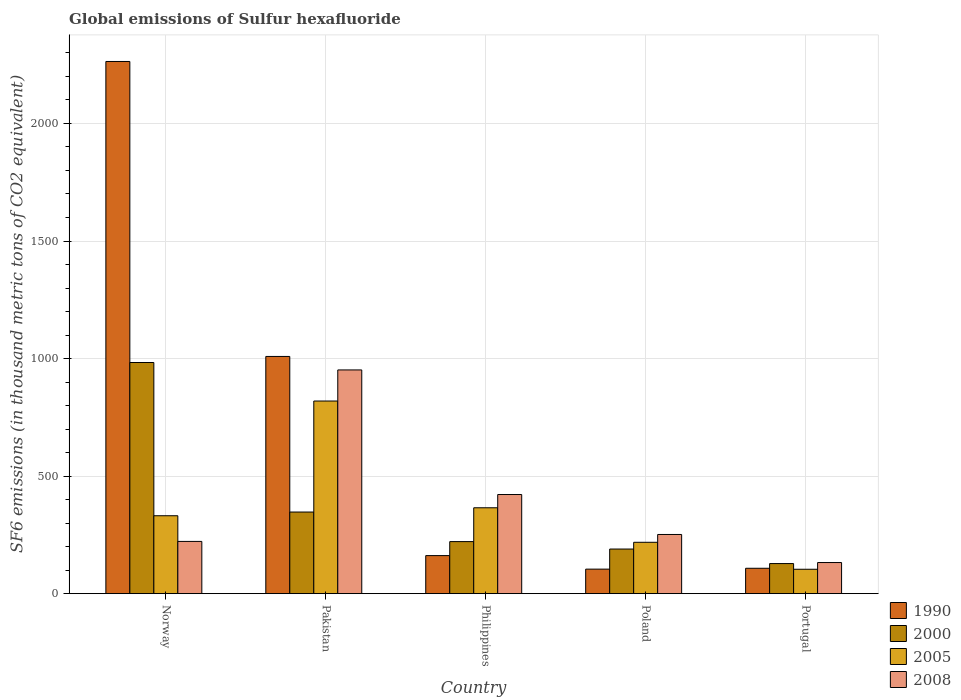How many groups of bars are there?
Ensure brevity in your answer.  5. Are the number of bars per tick equal to the number of legend labels?
Your answer should be compact. Yes. Are the number of bars on each tick of the X-axis equal?
Ensure brevity in your answer.  Yes. How many bars are there on the 1st tick from the left?
Provide a short and direct response. 4. What is the label of the 5th group of bars from the left?
Provide a succinct answer. Portugal. In how many cases, is the number of bars for a given country not equal to the number of legend labels?
Keep it short and to the point. 0. What is the global emissions of Sulfur hexafluoride in 2000 in Portugal?
Offer a very short reply. 128. Across all countries, what is the maximum global emissions of Sulfur hexafluoride in 2005?
Offer a terse response. 819.4. Across all countries, what is the minimum global emissions of Sulfur hexafluoride in 1990?
Your answer should be compact. 104.3. In which country was the global emissions of Sulfur hexafluoride in 1990 maximum?
Make the answer very short. Norway. In which country was the global emissions of Sulfur hexafluoride in 2005 minimum?
Provide a short and direct response. Portugal. What is the total global emissions of Sulfur hexafluoride in 2000 in the graph?
Provide a short and direct response. 1869.6. What is the difference between the global emissions of Sulfur hexafluoride in 2005 in Philippines and that in Portugal?
Keep it short and to the point. 261.5. What is the difference between the global emissions of Sulfur hexafluoride in 2000 in Poland and the global emissions of Sulfur hexafluoride in 2005 in Philippines?
Your response must be concise. -175.5. What is the average global emissions of Sulfur hexafluoride in 2005 per country?
Ensure brevity in your answer.  367.68. What is the difference between the global emissions of Sulfur hexafluoride of/in 2008 and global emissions of Sulfur hexafluoride of/in 2005 in Norway?
Give a very brief answer. -109.2. What is the ratio of the global emissions of Sulfur hexafluoride in 2000 in Norway to that in Philippines?
Offer a very short reply. 4.44. Is the global emissions of Sulfur hexafluoride in 2008 in Norway less than that in Poland?
Give a very brief answer. Yes. Is the difference between the global emissions of Sulfur hexafluoride in 2008 in Pakistan and Portugal greater than the difference between the global emissions of Sulfur hexafluoride in 2005 in Pakistan and Portugal?
Offer a very short reply. Yes. What is the difference between the highest and the second highest global emissions of Sulfur hexafluoride in 2000?
Your answer should be compact. 125.8. What is the difference between the highest and the lowest global emissions of Sulfur hexafluoride in 2000?
Ensure brevity in your answer.  855.2. What does the 4th bar from the left in Philippines represents?
Your answer should be compact. 2008. What does the 3rd bar from the right in Pakistan represents?
Give a very brief answer. 2000. Is it the case that in every country, the sum of the global emissions of Sulfur hexafluoride in 2005 and global emissions of Sulfur hexafluoride in 1990 is greater than the global emissions of Sulfur hexafluoride in 2000?
Your answer should be compact. Yes. Are all the bars in the graph horizontal?
Make the answer very short. No. Are the values on the major ticks of Y-axis written in scientific E-notation?
Keep it short and to the point. No. Does the graph contain any zero values?
Provide a short and direct response. No. Does the graph contain grids?
Offer a terse response. Yes. Where does the legend appear in the graph?
Give a very brief answer. Bottom right. How are the legend labels stacked?
Make the answer very short. Vertical. What is the title of the graph?
Offer a terse response. Global emissions of Sulfur hexafluoride. What is the label or title of the Y-axis?
Provide a short and direct response. SF6 emissions (in thousand metric tons of CO2 equivalent). What is the SF6 emissions (in thousand metric tons of CO2 equivalent) of 1990 in Norway?
Offer a terse response. 2263.6. What is the SF6 emissions (in thousand metric tons of CO2 equivalent) in 2000 in Norway?
Provide a short and direct response. 983.2. What is the SF6 emissions (in thousand metric tons of CO2 equivalent) of 2005 in Norway?
Your answer should be compact. 331.4. What is the SF6 emissions (in thousand metric tons of CO2 equivalent) of 2008 in Norway?
Ensure brevity in your answer.  222.2. What is the SF6 emissions (in thousand metric tons of CO2 equivalent) of 1990 in Pakistan?
Provide a succinct answer. 1009. What is the SF6 emissions (in thousand metric tons of CO2 equivalent) in 2000 in Pakistan?
Keep it short and to the point. 347.2. What is the SF6 emissions (in thousand metric tons of CO2 equivalent) of 2005 in Pakistan?
Make the answer very short. 819.4. What is the SF6 emissions (in thousand metric tons of CO2 equivalent) of 2008 in Pakistan?
Your answer should be compact. 951.6. What is the SF6 emissions (in thousand metric tons of CO2 equivalent) of 1990 in Philippines?
Your response must be concise. 161.9. What is the SF6 emissions (in thousand metric tons of CO2 equivalent) in 2000 in Philippines?
Your answer should be very brief. 221.4. What is the SF6 emissions (in thousand metric tons of CO2 equivalent) in 2005 in Philippines?
Give a very brief answer. 365.3. What is the SF6 emissions (in thousand metric tons of CO2 equivalent) in 2008 in Philippines?
Your response must be concise. 421.7. What is the SF6 emissions (in thousand metric tons of CO2 equivalent) in 1990 in Poland?
Your response must be concise. 104.3. What is the SF6 emissions (in thousand metric tons of CO2 equivalent) of 2000 in Poland?
Your response must be concise. 189.8. What is the SF6 emissions (in thousand metric tons of CO2 equivalent) of 2005 in Poland?
Offer a very short reply. 218.5. What is the SF6 emissions (in thousand metric tons of CO2 equivalent) of 2008 in Poland?
Give a very brief answer. 251.7. What is the SF6 emissions (in thousand metric tons of CO2 equivalent) in 1990 in Portugal?
Provide a succinct answer. 108. What is the SF6 emissions (in thousand metric tons of CO2 equivalent) in 2000 in Portugal?
Offer a very short reply. 128. What is the SF6 emissions (in thousand metric tons of CO2 equivalent) in 2005 in Portugal?
Offer a terse response. 103.8. What is the SF6 emissions (in thousand metric tons of CO2 equivalent) in 2008 in Portugal?
Your answer should be very brief. 132.4. Across all countries, what is the maximum SF6 emissions (in thousand metric tons of CO2 equivalent) in 1990?
Provide a short and direct response. 2263.6. Across all countries, what is the maximum SF6 emissions (in thousand metric tons of CO2 equivalent) in 2000?
Offer a terse response. 983.2. Across all countries, what is the maximum SF6 emissions (in thousand metric tons of CO2 equivalent) of 2005?
Ensure brevity in your answer.  819.4. Across all countries, what is the maximum SF6 emissions (in thousand metric tons of CO2 equivalent) in 2008?
Provide a succinct answer. 951.6. Across all countries, what is the minimum SF6 emissions (in thousand metric tons of CO2 equivalent) of 1990?
Give a very brief answer. 104.3. Across all countries, what is the minimum SF6 emissions (in thousand metric tons of CO2 equivalent) of 2000?
Provide a short and direct response. 128. Across all countries, what is the minimum SF6 emissions (in thousand metric tons of CO2 equivalent) of 2005?
Offer a terse response. 103.8. Across all countries, what is the minimum SF6 emissions (in thousand metric tons of CO2 equivalent) in 2008?
Make the answer very short. 132.4. What is the total SF6 emissions (in thousand metric tons of CO2 equivalent) in 1990 in the graph?
Keep it short and to the point. 3646.8. What is the total SF6 emissions (in thousand metric tons of CO2 equivalent) of 2000 in the graph?
Provide a succinct answer. 1869.6. What is the total SF6 emissions (in thousand metric tons of CO2 equivalent) in 2005 in the graph?
Your answer should be very brief. 1838.4. What is the total SF6 emissions (in thousand metric tons of CO2 equivalent) of 2008 in the graph?
Provide a succinct answer. 1979.6. What is the difference between the SF6 emissions (in thousand metric tons of CO2 equivalent) of 1990 in Norway and that in Pakistan?
Offer a very short reply. 1254.6. What is the difference between the SF6 emissions (in thousand metric tons of CO2 equivalent) in 2000 in Norway and that in Pakistan?
Provide a short and direct response. 636. What is the difference between the SF6 emissions (in thousand metric tons of CO2 equivalent) of 2005 in Norway and that in Pakistan?
Your answer should be compact. -488. What is the difference between the SF6 emissions (in thousand metric tons of CO2 equivalent) of 2008 in Norway and that in Pakistan?
Provide a succinct answer. -729.4. What is the difference between the SF6 emissions (in thousand metric tons of CO2 equivalent) in 1990 in Norway and that in Philippines?
Your answer should be compact. 2101.7. What is the difference between the SF6 emissions (in thousand metric tons of CO2 equivalent) of 2000 in Norway and that in Philippines?
Your answer should be compact. 761.8. What is the difference between the SF6 emissions (in thousand metric tons of CO2 equivalent) of 2005 in Norway and that in Philippines?
Provide a succinct answer. -33.9. What is the difference between the SF6 emissions (in thousand metric tons of CO2 equivalent) of 2008 in Norway and that in Philippines?
Provide a succinct answer. -199.5. What is the difference between the SF6 emissions (in thousand metric tons of CO2 equivalent) in 1990 in Norway and that in Poland?
Offer a very short reply. 2159.3. What is the difference between the SF6 emissions (in thousand metric tons of CO2 equivalent) of 2000 in Norway and that in Poland?
Make the answer very short. 793.4. What is the difference between the SF6 emissions (in thousand metric tons of CO2 equivalent) in 2005 in Norway and that in Poland?
Ensure brevity in your answer.  112.9. What is the difference between the SF6 emissions (in thousand metric tons of CO2 equivalent) of 2008 in Norway and that in Poland?
Offer a terse response. -29.5. What is the difference between the SF6 emissions (in thousand metric tons of CO2 equivalent) in 1990 in Norway and that in Portugal?
Your answer should be very brief. 2155.6. What is the difference between the SF6 emissions (in thousand metric tons of CO2 equivalent) of 2000 in Norway and that in Portugal?
Your answer should be very brief. 855.2. What is the difference between the SF6 emissions (in thousand metric tons of CO2 equivalent) of 2005 in Norway and that in Portugal?
Keep it short and to the point. 227.6. What is the difference between the SF6 emissions (in thousand metric tons of CO2 equivalent) of 2008 in Norway and that in Portugal?
Provide a succinct answer. 89.8. What is the difference between the SF6 emissions (in thousand metric tons of CO2 equivalent) of 1990 in Pakistan and that in Philippines?
Ensure brevity in your answer.  847.1. What is the difference between the SF6 emissions (in thousand metric tons of CO2 equivalent) in 2000 in Pakistan and that in Philippines?
Your answer should be very brief. 125.8. What is the difference between the SF6 emissions (in thousand metric tons of CO2 equivalent) of 2005 in Pakistan and that in Philippines?
Keep it short and to the point. 454.1. What is the difference between the SF6 emissions (in thousand metric tons of CO2 equivalent) of 2008 in Pakistan and that in Philippines?
Your answer should be compact. 529.9. What is the difference between the SF6 emissions (in thousand metric tons of CO2 equivalent) of 1990 in Pakistan and that in Poland?
Provide a short and direct response. 904.7. What is the difference between the SF6 emissions (in thousand metric tons of CO2 equivalent) of 2000 in Pakistan and that in Poland?
Make the answer very short. 157.4. What is the difference between the SF6 emissions (in thousand metric tons of CO2 equivalent) in 2005 in Pakistan and that in Poland?
Offer a very short reply. 600.9. What is the difference between the SF6 emissions (in thousand metric tons of CO2 equivalent) in 2008 in Pakistan and that in Poland?
Offer a very short reply. 699.9. What is the difference between the SF6 emissions (in thousand metric tons of CO2 equivalent) of 1990 in Pakistan and that in Portugal?
Your answer should be very brief. 901. What is the difference between the SF6 emissions (in thousand metric tons of CO2 equivalent) in 2000 in Pakistan and that in Portugal?
Your answer should be very brief. 219.2. What is the difference between the SF6 emissions (in thousand metric tons of CO2 equivalent) of 2005 in Pakistan and that in Portugal?
Offer a very short reply. 715.6. What is the difference between the SF6 emissions (in thousand metric tons of CO2 equivalent) of 2008 in Pakistan and that in Portugal?
Provide a short and direct response. 819.2. What is the difference between the SF6 emissions (in thousand metric tons of CO2 equivalent) in 1990 in Philippines and that in Poland?
Offer a terse response. 57.6. What is the difference between the SF6 emissions (in thousand metric tons of CO2 equivalent) in 2000 in Philippines and that in Poland?
Offer a very short reply. 31.6. What is the difference between the SF6 emissions (in thousand metric tons of CO2 equivalent) of 2005 in Philippines and that in Poland?
Make the answer very short. 146.8. What is the difference between the SF6 emissions (in thousand metric tons of CO2 equivalent) in 2008 in Philippines and that in Poland?
Offer a terse response. 170. What is the difference between the SF6 emissions (in thousand metric tons of CO2 equivalent) in 1990 in Philippines and that in Portugal?
Offer a very short reply. 53.9. What is the difference between the SF6 emissions (in thousand metric tons of CO2 equivalent) of 2000 in Philippines and that in Portugal?
Your answer should be very brief. 93.4. What is the difference between the SF6 emissions (in thousand metric tons of CO2 equivalent) in 2005 in Philippines and that in Portugal?
Offer a very short reply. 261.5. What is the difference between the SF6 emissions (in thousand metric tons of CO2 equivalent) in 2008 in Philippines and that in Portugal?
Offer a very short reply. 289.3. What is the difference between the SF6 emissions (in thousand metric tons of CO2 equivalent) of 1990 in Poland and that in Portugal?
Ensure brevity in your answer.  -3.7. What is the difference between the SF6 emissions (in thousand metric tons of CO2 equivalent) in 2000 in Poland and that in Portugal?
Provide a short and direct response. 61.8. What is the difference between the SF6 emissions (in thousand metric tons of CO2 equivalent) of 2005 in Poland and that in Portugal?
Offer a terse response. 114.7. What is the difference between the SF6 emissions (in thousand metric tons of CO2 equivalent) of 2008 in Poland and that in Portugal?
Provide a succinct answer. 119.3. What is the difference between the SF6 emissions (in thousand metric tons of CO2 equivalent) of 1990 in Norway and the SF6 emissions (in thousand metric tons of CO2 equivalent) of 2000 in Pakistan?
Offer a terse response. 1916.4. What is the difference between the SF6 emissions (in thousand metric tons of CO2 equivalent) of 1990 in Norway and the SF6 emissions (in thousand metric tons of CO2 equivalent) of 2005 in Pakistan?
Provide a succinct answer. 1444.2. What is the difference between the SF6 emissions (in thousand metric tons of CO2 equivalent) of 1990 in Norway and the SF6 emissions (in thousand metric tons of CO2 equivalent) of 2008 in Pakistan?
Your answer should be compact. 1312. What is the difference between the SF6 emissions (in thousand metric tons of CO2 equivalent) in 2000 in Norway and the SF6 emissions (in thousand metric tons of CO2 equivalent) in 2005 in Pakistan?
Keep it short and to the point. 163.8. What is the difference between the SF6 emissions (in thousand metric tons of CO2 equivalent) of 2000 in Norway and the SF6 emissions (in thousand metric tons of CO2 equivalent) of 2008 in Pakistan?
Your answer should be very brief. 31.6. What is the difference between the SF6 emissions (in thousand metric tons of CO2 equivalent) of 2005 in Norway and the SF6 emissions (in thousand metric tons of CO2 equivalent) of 2008 in Pakistan?
Give a very brief answer. -620.2. What is the difference between the SF6 emissions (in thousand metric tons of CO2 equivalent) of 1990 in Norway and the SF6 emissions (in thousand metric tons of CO2 equivalent) of 2000 in Philippines?
Your answer should be very brief. 2042.2. What is the difference between the SF6 emissions (in thousand metric tons of CO2 equivalent) in 1990 in Norway and the SF6 emissions (in thousand metric tons of CO2 equivalent) in 2005 in Philippines?
Your answer should be compact. 1898.3. What is the difference between the SF6 emissions (in thousand metric tons of CO2 equivalent) in 1990 in Norway and the SF6 emissions (in thousand metric tons of CO2 equivalent) in 2008 in Philippines?
Your answer should be very brief. 1841.9. What is the difference between the SF6 emissions (in thousand metric tons of CO2 equivalent) of 2000 in Norway and the SF6 emissions (in thousand metric tons of CO2 equivalent) of 2005 in Philippines?
Ensure brevity in your answer.  617.9. What is the difference between the SF6 emissions (in thousand metric tons of CO2 equivalent) in 2000 in Norway and the SF6 emissions (in thousand metric tons of CO2 equivalent) in 2008 in Philippines?
Keep it short and to the point. 561.5. What is the difference between the SF6 emissions (in thousand metric tons of CO2 equivalent) of 2005 in Norway and the SF6 emissions (in thousand metric tons of CO2 equivalent) of 2008 in Philippines?
Your answer should be compact. -90.3. What is the difference between the SF6 emissions (in thousand metric tons of CO2 equivalent) in 1990 in Norway and the SF6 emissions (in thousand metric tons of CO2 equivalent) in 2000 in Poland?
Keep it short and to the point. 2073.8. What is the difference between the SF6 emissions (in thousand metric tons of CO2 equivalent) of 1990 in Norway and the SF6 emissions (in thousand metric tons of CO2 equivalent) of 2005 in Poland?
Offer a very short reply. 2045.1. What is the difference between the SF6 emissions (in thousand metric tons of CO2 equivalent) of 1990 in Norway and the SF6 emissions (in thousand metric tons of CO2 equivalent) of 2008 in Poland?
Your answer should be very brief. 2011.9. What is the difference between the SF6 emissions (in thousand metric tons of CO2 equivalent) of 2000 in Norway and the SF6 emissions (in thousand metric tons of CO2 equivalent) of 2005 in Poland?
Your answer should be very brief. 764.7. What is the difference between the SF6 emissions (in thousand metric tons of CO2 equivalent) in 2000 in Norway and the SF6 emissions (in thousand metric tons of CO2 equivalent) in 2008 in Poland?
Offer a very short reply. 731.5. What is the difference between the SF6 emissions (in thousand metric tons of CO2 equivalent) in 2005 in Norway and the SF6 emissions (in thousand metric tons of CO2 equivalent) in 2008 in Poland?
Provide a succinct answer. 79.7. What is the difference between the SF6 emissions (in thousand metric tons of CO2 equivalent) of 1990 in Norway and the SF6 emissions (in thousand metric tons of CO2 equivalent) of 2000 in Portugal?
Your answer should be very brief. 2135.6. What is the difference between the SF6 emissions (in thousand metric tons of CO2 equivalent) in 1990 in Norway and the SF6 emissions (in thousand metric tons of CO2 equivalent) in 2005 in Portugal?
Offer a very short reply. 2159.8. What is the difference between the SF6 emissions (in thousand metric tons of CO2 equivalent) of 1990 in Norway and the SF6 emissions (in thousand metric tons of CO2 equivalent) of 2008 in Portugal?
Your answer should be compact. 2131.2. What is the difference between the SF6 emissions (in thousand metric tons of CO2 equivalent) of 2000 in Norway and the SF6 emissions (in thousand metric tons of CO2 equivalent) of 2005 in Portugal?
Your answer should be compact. 879.4. What is the difference between the SF6 emissions (in thousand metric tons of CO2 equivalent) in 2000 in Norway and the SF6 emissions (in thousand metric tons of CO2 equivalent) in 2008 in Portugal?
Keep it short and to the point. 850.8. What is the difference between the SF6 emissions (in thousand metric tons of CO2 equivalent) in 2005 in Norway and the SF6 emissions (in thousand metric tons of CO2 equivalent) in 2008 in Portugal?
Offer a terse response. 199. What is the difference between the SF6 emissions (in thousand metric tons of CO2 equivalent) in 1990 in Pakistan and the SF6 emissions (in thousand metric tons of CO2 equivalent) in 2000 in Philippines?
Keep it short and to the point. 787.6. What is the difference between the SF6 emissions (in thousand metric tons of CO2 equivalent) in 1990 in Pakistan and the SF6 emissions (in thousand metric tons of CO2 equivalent) in 2005 in Philippines?
Ensure brevity in your answer.  643.7. What is the difference between the SF6 emissions (in thousand metric tons of CO2 equivalent) of 1990 in Pakistan and the SF6 emissions (in thousand metric tons of CO2 equivalent) of 2008 in Philippines?
Ensure brevity in your answer.  587.3. What is the difference between the SF6 emissions (in thousand metric tons of CO2 equivalent) in 2000 in Pakistan and the SF6 emissions (in thousand metric tons of CO2 equivalent) in 2005 in Philippines?
Offer a very short reply. -18.1. What is the difference between the SF6 emissions (in thousand metric tons of CO2 equivalent) of 2000 in Pakistan and the SF6 emissions (in thousand metric tons of CO2 equivalent) of 2008 in Philippines?
Keep it short and to the point. -74.5. What is the difference between the SF6 emissions (in thousand metric tons of CO2 equivalent) of 2005 in Pakistan and the SF6 emissions (in thousand metric tons of CO2 equivalent) of 2008 in Philippines?
Your answer should be compact. 397.7. What is the difference between the SF6 emissions (in thousand metric tons of CO2 equivalent) of 1990 in Pakistan and the SF6 emissions (in thousand metric tons of CO2 equivalent) of 2000 in Poland?
Provide a succinct answer. 819.2. What is the difference between the SF6 emissions (in thousand metric tons of CO2 equivalent) in 1990 in Pakistan and the SF6 emissions (in thousand metric tons of CO2 equivalent) in 2005 in Poland?
Keep it short and to the point. 790.5. What is the difference between the SF6 emissions (in thousand metric tons of CO2 equivalent) of 1990 in Pakistan and the SF6 emissions (in thousand metric tons of CO2 equivalent) of 2008 in Poland?
Provide a succinct answer. 757.3. What is the difference between the SF6 emissions (in thousand metric tons of CO2 equivalent) of 2000 in Pakistan and the SF6 emissions (in thousand metric tons of CO2 equivalent) of 2005 in Poland?
Your response must be concise. 128.7. What is the difference between the SF6 emissions (in thousand metric tons of CO2 equivalent) of 2000 in Pakistan and the SF6 emissions (in thousand metric tons of CO2 equivalent) of 2008 in Poland?
Your response must be concise. 95.5. What is the difference between the SF6 emissions (in thousand metric tons of CO2 equivalent) of 2005 in Pakistan and the SF6 emissions (in thousand metric tons of CO2 equivalent) of 2008 in Poland?
Your answer should be very brief. 567.7. What is the difference between the SF6 emissions (in thousand metric tons of CO2 equivalent) in 1990 in Pakistan and the SF6 emissions (in thousand metric tons of CO2 equivalent) in 2000 in Portugal?
Keep it short and to the point. 881. What is the difference between the SF6 emissions (in thousand metric tons of CO2 equivalent) in 1990 in Pakistan and the SF6 emissions (in thousand metric tons of CO2 equivalent) in 2005 in Portugal?
Provide a short and direct response. 905.2. What is the difference between the SF6 emissions (in thousand metric tons of CO2 equivalent) of 1990 in Pakistan and the SF6 emissions (in thousand metric tons of CO2 equivalent) of 2008 in Portugal?
Ensure brevity in your answer.  876.6. What is the difference between the SF6 emissions (in thousand metric tons of CO2 equivalent) of 2000 in Pakistan and the SF6 emissions (in thousand metric tons of CO2 equivalent) of 2005 in Portugal?
Offer a very short reply. 243.4. What is the difference between the SF6 emissions (in thousand metric tons of CO2 equivalent) in 2000 in Pakistan and the SF6 emissions (in thousand metric tons of CO2 equivalent) in 2008 in Portugal?
Your answer should be compact. 214.8. What is the difference between the SF6 emissions (in thousand metric tons of CO2 equivalent) in 2005 in Pakistan and the SF6 emissions (in thousand metric tons of CO2 equivalent) in 2008 in Portugal?
Your response must be concise. 687. What is the difference between the SF6 emissions (in thousand metric tons of CO2 equivalent) in 1990 in Philippines and the SF6 emissions (in thousand metric tons of CO2 equivalent) in 2000 in Poland?
Your response must be concise. -27.9. What is the difference between the SF6 emissions (in thousand metric tons of CO2 equivalent) in 1990 in Philippines and the SF6 emissions (in thousand metric tons of CO2 equivalent) in 2005 in Poland?
Give a very brief answer. -56.6. What is the difference between the SF6 emissions (in thousand metric tons of CO2 equivalent) in 1990 in Philippines and the SF6 emissions (in thousand metric tons of CO2 equivalent) in 2008 in Poland?
Make the answer very short. -89.8. What is the difference between the SF6 emissions (in thousand metric tons of CO2 equivalent) in 2000 in Philippines and the SF6 emissions (in thousand metric tons of CO2 equivalent) in 2005 in Poland?
Your answer should be very brief. 2.9. What is the difference between the SF6 emissions (in thousand metric tons of CO2 equivalent) of 2000 in Philippines and the SF6 emissions (in thousand metric tons of CO2 equivalent) of 2008 in Poland?
Your answer should be compact. -30.3. What is the difference between the SF6 emissions (in thousand metric tons of CO2 equivalent) in 2005 in Philippines and the SF6 emissions (in thousand metric tons of CO2 equivalent) in 2008 in Poland?
Ensure brevity in your answer.  113.6. What is the difference between the SF6 emissions (in thousand metric tons of CO2 equivalent) in 1990 in Philippines and the SF6 emissions (in thousand metric tons of CO2 equivalent) in 2000 in Portugal?
Provide a short and direct response. 33.9. What is the difference between the SF6 emissions (in thousand metric tons of CO2 equivalent) of 1990 in Philippines and the SF6 emissions (in thousand metric tons of CO2 equivalent) of 2005 in Portugal?
Your answer should be compact. 58.1. What is the difference between the SF6 emissions (in thousand metric tons of CO2 equivalent) in 1990 in Philippines and the SF6 emissions (in thousand metric tons of CO2 equivalent) in 2008 in Portugal?
Offer a very short reply. 29.5. What is the difference between the SF6 emissions (in thousand metric tons of CO2 equivalent) of 2000 in Philippines and the SF6 emissions (in thousand metric tons of CO2 equivalent) of 2005 in Portugal?
Provide a short and direct response. 117.6. What is the difference between the SF6 emissions (in thousand metric tons of CO2 equivalent) in 2000 in Philippines and the SF6 emissions (in thousand metric tons of CO2 equivalent) in 2008 in Portugal?
Make the answer very short. 89. What is the difference between the SF6 emissions (in thousand metric tons of CO2 equivalent) in 2005 in Philippines and the SF6 emissions (in thousand metric tons of CO2 equivalent) in 2008 in Portugal?
Your answer should be very brief. 232.9. What is the difference between the SF6 emissions (in thousand metric tons of CO2 equivalent) of 1990 in Poland and the SF6 emissions (in thousand metric tons of CO2 equivalent) of 2000 in Portugal?
Provide a succinct answer. -23.7. What is the difference between the SF6 emissions (in thousand metric tons of CO2 equivalent) of 1990 in Poland and the SF6 emissions (in thousand metric tons of CO2 equivalent) of 2008 in Portugal?
Offer a very short reply. -28.1. What is the difference between the SF6 emissions (in thousand metric tons of CO2 equivalent) of 2000 in Poland and the SF6 emissions (in thousand metric tons of CO2 equivalent) of 2008 in Portugal?
Give a very brief answer. 57.4. What is the difference between the SF6 emissions (in thousand metric tons of CO2 equivalent) of 2005 in Poland and the SF6 emissions (in thousand metric tons of CO2 equivalent) of 2008 in Portugal?
Your answer should be very brief. 86.1. What is the average SF6 emissions (in thousand metric tons of CO2 equivalent) of 1990 per country?
Ensure brevity in your answer.  729.36. What is the average SF6 emissions (in thousand metric tons of CO2 equivalent) of 2000 per country?
Ensure brevity in your answer.  373.92. What is the average SF6 emissions (in thousand metric tons of CO2 equivalent) of 2005 per country?
Make the answer very short. 367.68. What is the average SF6 emissions (in thousand metric tons of CO2 equivalent) of 2008 per country?
Keep it short and to the point. 395.92. What is the difference between the SF6 emissions (in thousand metric tons of CO2 equivalent) in 1990 and SF6 emissions (in thousand metric tons of CO2 equivalent) in 2000 in Norway?
Your response must be concise. 1280.4. What is the difference between the SF6 emissions (in thousand metric tons of CO2 equivalent) of 1990 and SF6 emissions (in thousand metric tons of CO2 equivalent) of 2005 in Norway?
Your answer should be compact. 1932.2. What is the difference between the SF6 emissions (in thousand metric tons of CO2 equivalent) of 1990 and SF6 emissions (in thousand metric tons of CO2 equivalent) of 2008 in Norway?
Ensure brevity in your answer.  2041.4. What is the difference between the SF6 emissions (in thousand metric tons of CO2 equivalent) in 2000 and SF6 emissions (in thousand metric tons of CO2 equivalent) in 2005 in Norway?
Keep it short and to the point. 651.8. What is the difference between the SF6 emissions (in thousand metric tons of CO2 equivalent) of 2000 and SF6 emissions (in thousand metric tons of CO2 equivalent) of 2008 in Norway?
Ensure brevity in your answer.  761. What is the difference between the SF6 emissions (in thousand metric tons of CO2 equivalent) of 2005 and SF6 emissions (in thousand metric tons of CO2 equivalent) of 2008 in Norway?
Keep it short and to the point. 109.2. What is the difference between the SF6 emissions (in thousand metric tons of CO2 equivalent) in 1990 and SF6 emissions (in thousand metric tons of CO2 equivalent) in 2000 in Pakistan?
Your response must be concise. 661.8. What is the difference between the SF6 emissions (in thousand metric tons of CO2 equivalent) in 1990 and SF6 emissions (in thousand metric tons of CO2 equivalent) in 2005 in Pakistan?
Ensure brevity in your answer.  189.6. What is the difference between the SF6 emissions (in thousand metric tons of CO2 equivalent) of 1990 and SF6 emissions (in thousand metric tons of CO2 equivalent) of 2008 in Pakistan?
Give a very brief answer. 57.4. What is the difference between the SF6 emissions (in thousand metric tons of CO2 equivalent) in 2000 and SF6 emissions (in thousand metric tons of CO2 equivalent) in 2005 in Pakistan?
Provide a succinct answer. -472.2. What is the difference between the SF6 emissions (in thousand metric tons of CO2 equivalent) of 2000 and SF6 emissions (in thousand metric tons of CO2 equivalent) of 2008 in Pakistan?
Your answer should be compact. -604.4. What is the difference between the SF6 emissions (in thousand metric tons of CO2 equivalent) in 2005 and SF6 emissions (in thousand metric tons of CO2 equivalent) in 2008 in Pakistan?
Give a very brief answer. -132.2. What is the difference between the SF6 emissions (in thousand metric tons of CO2 equivalent) of 1990 and SF6 emissions (in thousand metric tons of CO2 equivalent) of 2000 in Philippines?
Offer a very short reply. -59.5. What is the difference between the SF6 emissions (in thousand metric tons of CO2 equivalent) in 1990 and SF6 emissions (in thousand metric tons of CO2 equivalent) in 2005 in Philippines?
Make the answer very short. -203.4. What is the difference between the SF6 emissions (in thousand metric tons of CO2 equivalent) in 1990 and SF6 emissions (in thousand metric tons of CO2 equivalent) in 2008 in Philippines?
Your response must be concise. -259.8. What is the difference between the SF6 emissions (in thousand metric tons of CO2 equivalent) of 2000 and SF6 emissions (in thousand metric tons of CO2 equivalent) of 2005 in Philippines?
Provide a succinct answer. -143.9. What is the difference between the SF6 emissions (in thousand metric tons of CO2 equivalent) of 2000 and SF6 emissions (in thousand metric tons of CO2 equivalent) of 2008 in Philippines?
Ensure brevity in your answer.  -200.3. What is the difference between the SF6 emissions (in thousand metric tons of CO2 equivalent) of 2005 and SF6 emissions (in thousand metric tons of CO2 equivalent) of 2008 in Philippines?
Keep it short and to the point. -56.4. What is the difference between the SF6 emissions (in thousand metric tons of CO2 equivalent) in 1990 and SF6 emissions (in thousand metric tons of CO2 equivalent) in 2000 in Poland?
Your answer should be very brief. -85.5. What is the difference between the SF6 emissions (in thousand metric tons of CO2 equivalent) in 1990 and SF6 emissions (in thousand metric tons of CO2 equivalent) in 2005 in Poland?
Offer a very short reply. -114.2. What is the difference between the SF6 emissions (in thousand metric tons of CO2 equivalent) in 1990 and SF6 emissions (in thousand metric tons of CO2 equivalent) in 2008 in Poland?
Provide a succinct answer. -147.4. What is the difference between the SF6 emissions (in thousand metric tons of CO2 equivalent) of 2000 and SF6 emissions (in thousand metric tons of CO2 equivalent) of 2005 in Poland?
Provide a short and direct response. -28.7. What is the difference between the SF6 emissions (in thousand metric tons of CO2 equivalent) of 2000 and SF6 emissions (in thousand metric tons of CO2 equivalent) of 2008 in Poland?
Make the answer very short. -61.9. What is the difference between the SF6 emissions (in thousand metric tons of CO2 equivalent) in 2005 and SF6 emissions (in thousand metric tons of CO2 equivalent) in 2008 in Poland?
Provide a succinct answer. -33.2. What is the difference between the SF6 emissions (in thousand metric tons of CO2 equivalent) in 1990 and SF6 emissions (in thousand metric tons of CO2 equivalent) in 2000 in Portugal?
Provide a short and direct response. -20. What is the difference between the SF6 emissions (in thousand metric tons of CO2 equivalent) of 1990 and SF6 emissions (in thousand metric tons of CO2 equivalent) of 2005 in Portugal?
Provide a short and direct response. 4.2. What is the difference between the SF6 emissions (in thousand metric tons of CO2 equivalent) in 1990 and SF6 emissions (in thousand metric tons of CO2 equivalent) in 2008 in Portugal?
Provide a succinct answer. -24.4. What is the difference between the SF6 emissions (in thousand metric tons of CO2 equivalent) of 2000 and SF6 emissions (in thousand metric tons of CO2 equivalent) of 2005 in Portugal?
Keep it short and to the point. 24.2. What is the difference between the SF6 emissions (in thousand metric tons of CO2 equivalent) in 2005 and SF6 emissions (in thousand metric tons of CO2 equivalent) in 2008 in Portugal?
Provide a short and direct response. -28.6. What is the ratio of the SF6 emissions (in thousand metric tons of CO2 equivalent) of 1990 in Norway to that in Pakistan?
Your response must be concise. 2.24. What is the ratio of the SF6 emissions (in thousand metric tons of CO2 equivalent) of 2000 in Norway to that in Pakistan?
Provide a short and direct response. 2.83. What is the ratio of the SF6 emissions (in thousand metric tons of CO2 equivalent) in 2005 in Norway to that in Pakistan?
Your response must be concise. 0.4. What is the ratio of the SF6 emissions (in thousand metric tons of CO2 equivalent) of 2008 in Norway to that in Pakistan?
Give a very brief answer. 0.23. What is the ratio of the SF6 emissions (in thousand metric tons of CO2 equivalent) in 1990 in Norway to that in Philippines?
Keep it short and to the point. 13.98. What is the ratio of the SF6 emissions (in thousand metric tons of CO2 equivalent) of 2000 in Norway to that in Philippines?
Keep it short and to the point. 4.44. What is the ratio of the SF6 emissions (in thousand metric tons of CO2 equivalent) of 2005 in Norway to that in Philippines?
Provide a succinct answer. 0.91. What is the ratio of the SF6 emissions (in thousand metric tons of CO2 equivalent) of 2008 in Norway to that in Philippines?
Provide a succinct answer. 0.53. What is the ratio of the SF6 emissions (in thousand metric tons of CO2 equivalent) of 1990 in Norway to that in Poland?
Make the answer very short. 21.7. What is the ratio of the SF6 emissions (in thousand metric tons of CO2 equivalent) in 2000 in Norway to that in Poland?
Your response must be concise. 5.18. What is the ratio of the SF6 emissions (in thousand metric tons of CO2 equivalent) in 2005 in Norway to that in Poland?
Your response must be concise. 1.52. What is the ratio of the SF6 emissions (in thousand metric tons of CO2 equivalent) of 2008 in Norway to that in Poland?
Your answer should be very brief. 0.88. What is the ratio of the SF6 emissions (in thousand metric tons of CO2 equivalent) of 1990 in Norway to that in Portugal?
Your response must be concise. 20.96. What is the ratio of the SF6 emissions (in thousand metric tons of CO2 equivalent) in 2000 in Norway to that in Portugal?
Offer a terse response. 7.68. What is the ratio of the SF6 emissions (in thousand metric tons of CO2 equivalent) of 2005 in Norway to that in Portugal?
Your response must be concise. 3.19. What is the ratio of the SF6 emissions (in thousand metric tons of CO2 equivalent) in 2008 in Norway to that in Portugal?
Ensure brevity in your answer.  1.68. What is the ratio of the SF6 emissions (in thousand metric tons of CO2 equivalent) of 1990 in Pakistan to that in Philippines?
Ensure brevity in your answer.  6.23. What is the ratio of the SF6 emissions (in thousand metric tons of CO2 equivalent) of 2000 in Pakistan to that in Philippines?
Keep it short and to the point. 1.57. What is the ratio of the SF6 emissions (in thousand metric tons of CO2 equivalent) of 2005 in Pakistan to that in Philippines?
Make the answer very short. 2.24. What is the ratio of the SF6 emissions (in thousand metric tons of CO2 equivalent) of 2008 in Pakistan to that in Philippines?
Offer a terse response. 2.26. What is the ratio of the SF6 emissions (in thousand metric tons of CO2 equivalent) of 1990 in Pakistan to that in Poland?
Offer a terse response. 9.67. What is the ratio of the SF6 emissions (in thousand metric tons of CO2 equivalent) in 2000 in Pakistan to that in Poland?
Keep it short and to the point. 1.83. What is the ratio of the SF6 emissions (in thousand metric tons of CO2 equivalent) of 2005 in Pakistan to that in Poland?
Offer a terse response. 3.75. What is the ratio of the SF6 emissions (in thousand metric tons of CO2 equivalent) in 2008 in Pakistan to that in Poland?
Make the answer very short. 3.78. What is the ratio of the SF6 emissions (in thousand metric tons of CO2 equivalent) of 1990 in Pakistan to that in Portugal?
Your response must be concise. 9.34. What is the ratio of the SF6 emissions (in thousand metric tons of CO2 equivalent) of 2000 in Pakistan to that in Portugal?
Your response must be concise. 2.71. What is the ratio of the SF6 emissions (in thousand metric tons of CO2 equivalent) of 2005 in Pakistan to that in Portugal?
Offer a terse response. 7.89. What is the ratio of the SF6 emissions (in thousand metric tons of CO2 equivalent) of 2008 in Pakistan to that in Portugal?
Your answer should be compact. 7.19. What is the ratio of the SF6 emissions (in thousand metric tons of CO2 equivalent) of 1990 in Philippines to that in Poland?
Ensure brevity in your answer.  1.55. What is the ratio of the SF6 emissions (in thousand metric tons of CO2 equivalent) of 2000 in Philippines to that in Poland?
Ensure brevity in your answer.  1.17. What is the ratio of the SF6 emissions (in thousand metric tons of CO2 equivalent) of 2005 in Philippines to that in Poland?
Your response must be concise. 1.67. What is the ratio of the SF6 emissions (in thousand metric tons of CO2 equivalent) of 2008 in Philippines to that in Poland?
Make the answer very short. 1.68. What is the ratio of the SF6 emissions (in thousand metric tons of CO2 equivalent) of 1990 in Philippines to that in Portugal?
Ensure brevity in your answer.  1.5. What is the ratio of the SF6 emissions (in thousand metric tons of CO2 equivalent) of 2000 in Philippines to that in Portugal?
Offer a terse response. 1.73. What is the ratio of the SF6 emissions (in thousand metric tons of CO2 equivalent) of 2005 in Philippines to that in Portugal?
Offer a very short reply. 3.52. What is the ratio of the SF6 emissions (in thousand metric tons of CO2 equivalent) in 2008 in Philippines to that in Portugal?
Keep it short and to the point. 3.19. What is the ratio of the SF6 emissions (in thousand metric tons of CO2 equivalent) in 1990 in Poland to that in Portugal?
Give a very brief answer. 0.97. What is the ratio of the SF6 emissions (in thousand metric tons of CO2 equivalent) of 2000 in Poland to that in Portugal?
Keep it short and to the point. 1.48. What is the ratio of the SF6 emissions (in thousand metric tons of CO2 equivalent) in 2005 in Poland to that in Portugal?
Offer a terse response. 2.1. What is the ratio of the SF6 emissions (in thousand metric tons of CO2 equivalent) of 2008 in Poland to that in Portugal?
Your answer should be compact. 1.9. What is the difference between the highest and the second highest SF6 emissions (in thousand metric tons of CO2 equivalent) in 1990?
Provide a short and direct response. 1254.6. What is the difference between the highest and the second highest SF6 emissions (in thousand metric tons of CO2 equivalent) of 2000?
Ensure brevity in your answer.  636. What is the difference between the highest and the second highest SF6 emissions (in thousand metric tons of CO2 equivalent) in 2005?
Provide a succinct answer. 454.1. What is the difference between the highest and the second highest SF6 emissions (in thousand metric tons of CO2 equivalent) of 2008?
Your answer should be very brief. 529.9. What is the difference between the highest and the lowest SF6 emissions (in thousand metric tons of CO2 equivalent) in 1990?
Offer a terse response. 2159.3. What is the difference between the highest and the lowest SF6 emissions (in thousand metric tons of CO2 equivalent) of 2000?
Ensure brevity in your answer.  855.2. What is the difference between the highest and the lowest SF6 emissions (in thousand metric tons of CO2 equivalent) of 2005?
Offer a terse response. 715.6. What is the difference between the highest and the lowest SF6 emissions (in thousand metric tons of CO2 equivalent) in 2008?
Give a very brief answer. 819.2. 